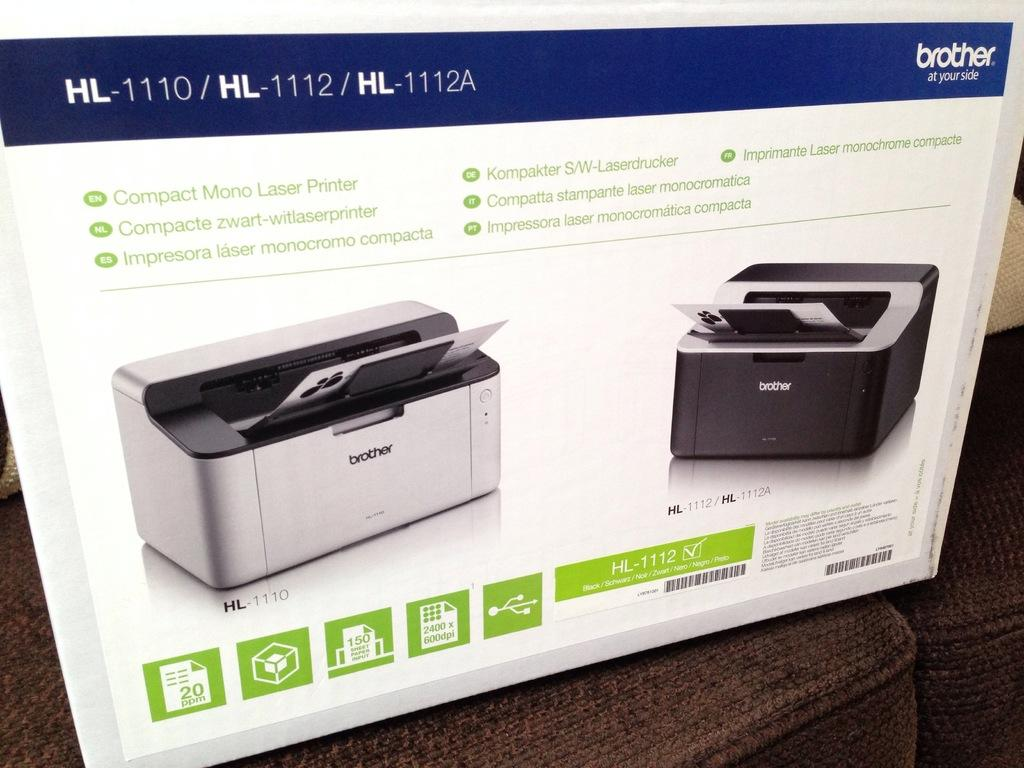<image>
Relay a brief, clear account of the picture shown. a computer printer box from Brother for HL-1110 